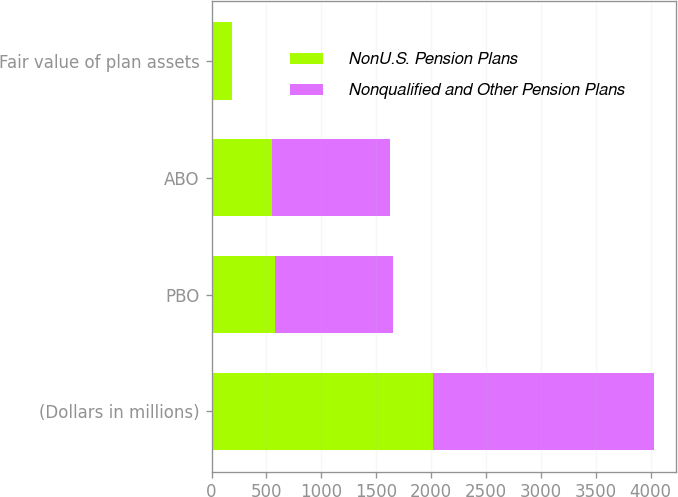Convert chart to OTSL. <chart><loc_0><loc_0><loc_500><loc_500><stacked_bar_chart><ecel><fcel>(Dollars in millions)<fcel>PBO<fcel>ABO<fcel>Fair value of plan assets<nl><fcel>NonU.S. Pension Plans<fcel>2015<fcel>574<fcel>551<fcel>183<nl><fcel>Nonqualified and Other Pension Plans<fcel>2015<fcel>1075<fcel>1074<fcel>1<nl></chart> 